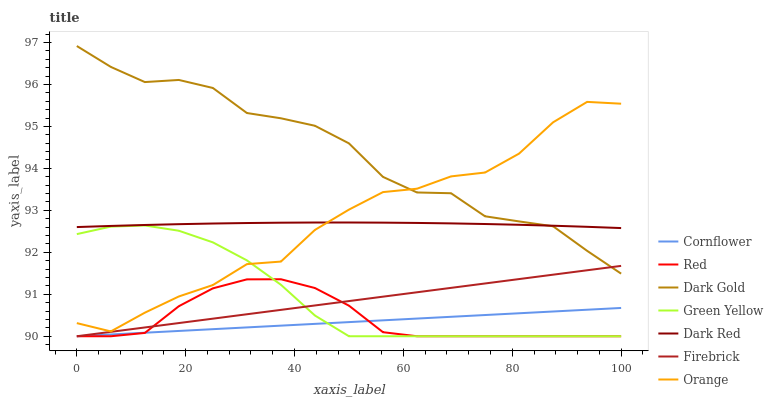Does Cornflower have the minimum area under the curve?
Answer yes or no. Yes. Does Dark Gold have the maximum area under the curve?
Answer yes or no. Yes. Does Dark Red have the minimum area under the curve?
Answer yes or no. No. Does Dark Red have the maximum area under the curve?
Answer yes or no. No. Is Cornflower the smoothest?
Answer yes or no. Yes. Is Orange the roughest?
Answer yes or no. Yes. Is Dark Gold the smoothest?
Answer yes or no. No. Is Dark Gold the roughest?
Answer yes or no. No. Does Cornflower have the lowest value?
Answer yes or no. Yes. Does Dark Gold have the lowest value?
Answer yes or no. No. Does Dark Gold have the highest value?
Answer yes or no. Yes. Does Dark Red have the highest value?
Answer yes or no. No. Is Firebrick less than Orange?
Answer yes or no. Yes. Is Dark Gold greater than Cornflower?
Answer yes or no. Yes. Does Orange intersect Dark Red?
Answer yes or no. Yes. Is Orange less than Dark Red?
Answer yes or no. No. Is Orange greater than Dark Red?
Answer yes or no. No. Does Firebrick intersect Orange?
Answer yes or no. No. 